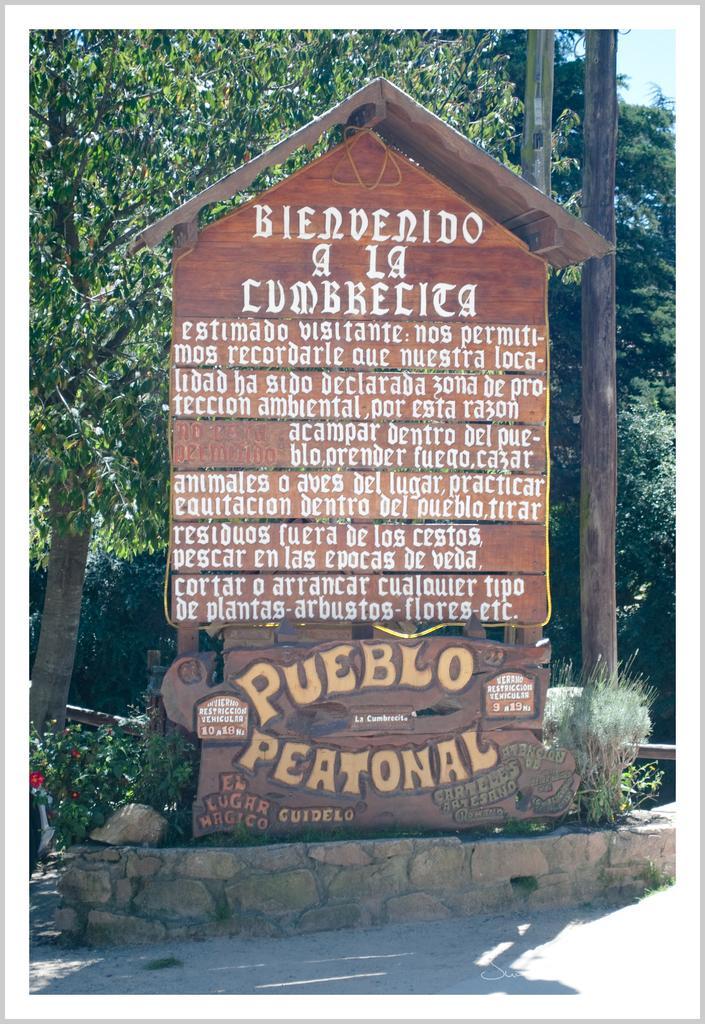Please provide a concise description of this image. In this image I can see in the middle there is a board with text written on it. At the back side there are trees, at the top it is the sky. 